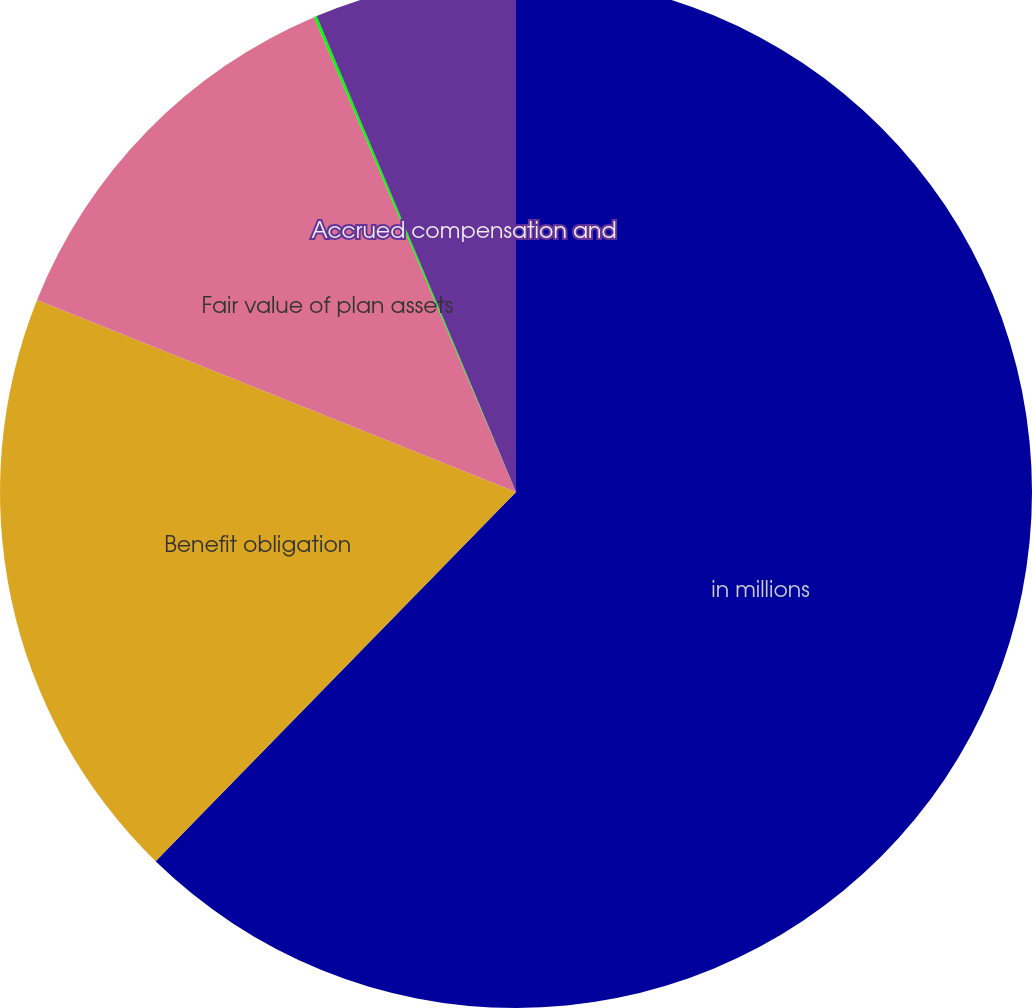<chart> <loc_0><loc_0><loc_500><loc_500><pie_chart><fcel>in millions<fcel>Benefit obligation<fcel>Fair value of plan assets<fcel>Funded status<fcel>Accrued compensation and<nl><fcel>62.3%<fcel>18.76%<fcel>12.53%<fcel>0.09%<fcel>6.31%<nl></chart> 